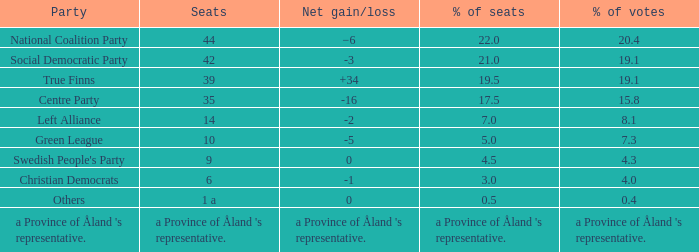When the swedish people's party underwent a net rise/fall of 0, how many seats were in their control? 9.0. 